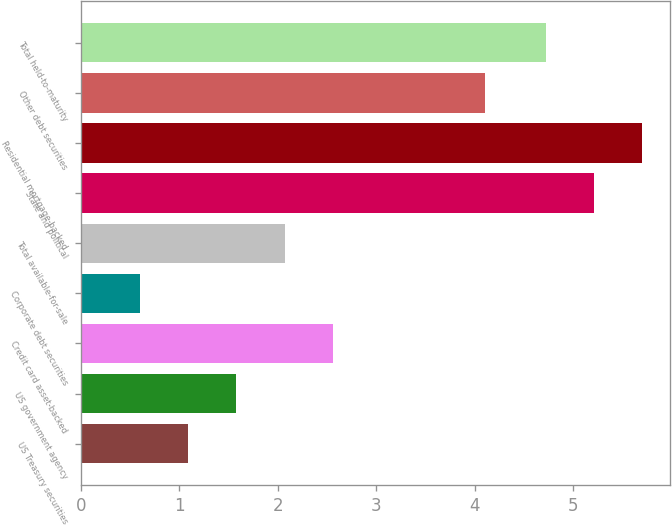<chart> <loc_0><loc_0><loc_500><loc_500><bar_chart><fcel>US Treasury securities<fcel>US government agency<fcel>Credit card asset-backed<fcel>Corporate debt securities<fcel>Total available-for-sale<fcel>State and political<fcel>Residential mortgage-backed<fcel>Other debt securities<fcel>Total held-to-maturity<nl><fcel>1.09<fcel>1.58<fcel>2.56<fcel>0.6<fcel>2.07<fcel>5.21<fcel>5.7<fcel>4.1<fcel>4.72<nl></chart> 